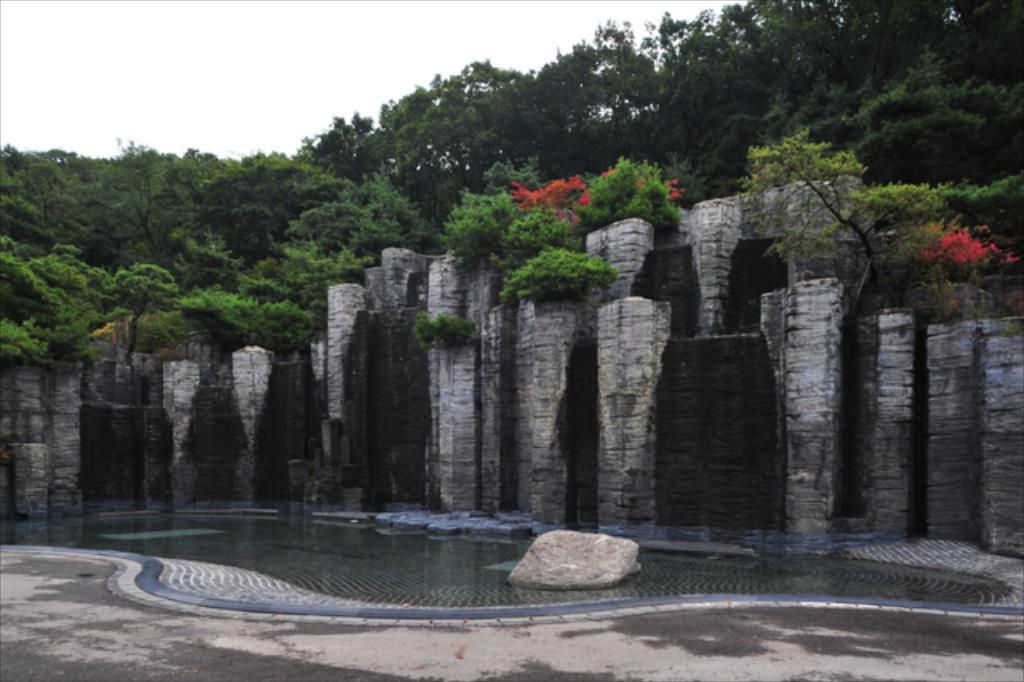Please provide a concise description of this image. In the center of the image, we can see pillars and there is a wall and there are plants and trees. At the bottom, there is a rock on the water and there is a road. 